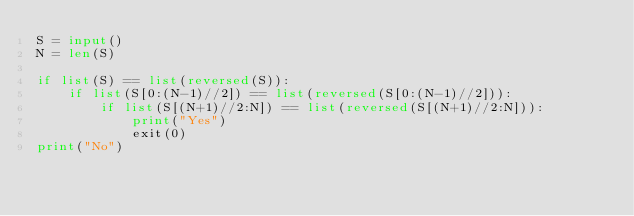Convert code to text. <code><loc_0><loc_0><loc_500><loc_500><_Python_>S = input()
N = len(S)

if list(S) == list(reversed(S)):
    if list(S[0:(N-1)//2]) == list(reversed(S[0:(N-1)//2])):
        if list(S[(N+1)//2:N]) == list(reversed(S[(N+1)//2:N])):
            print("Yes")
            exit(0)
print("No")
</code> 